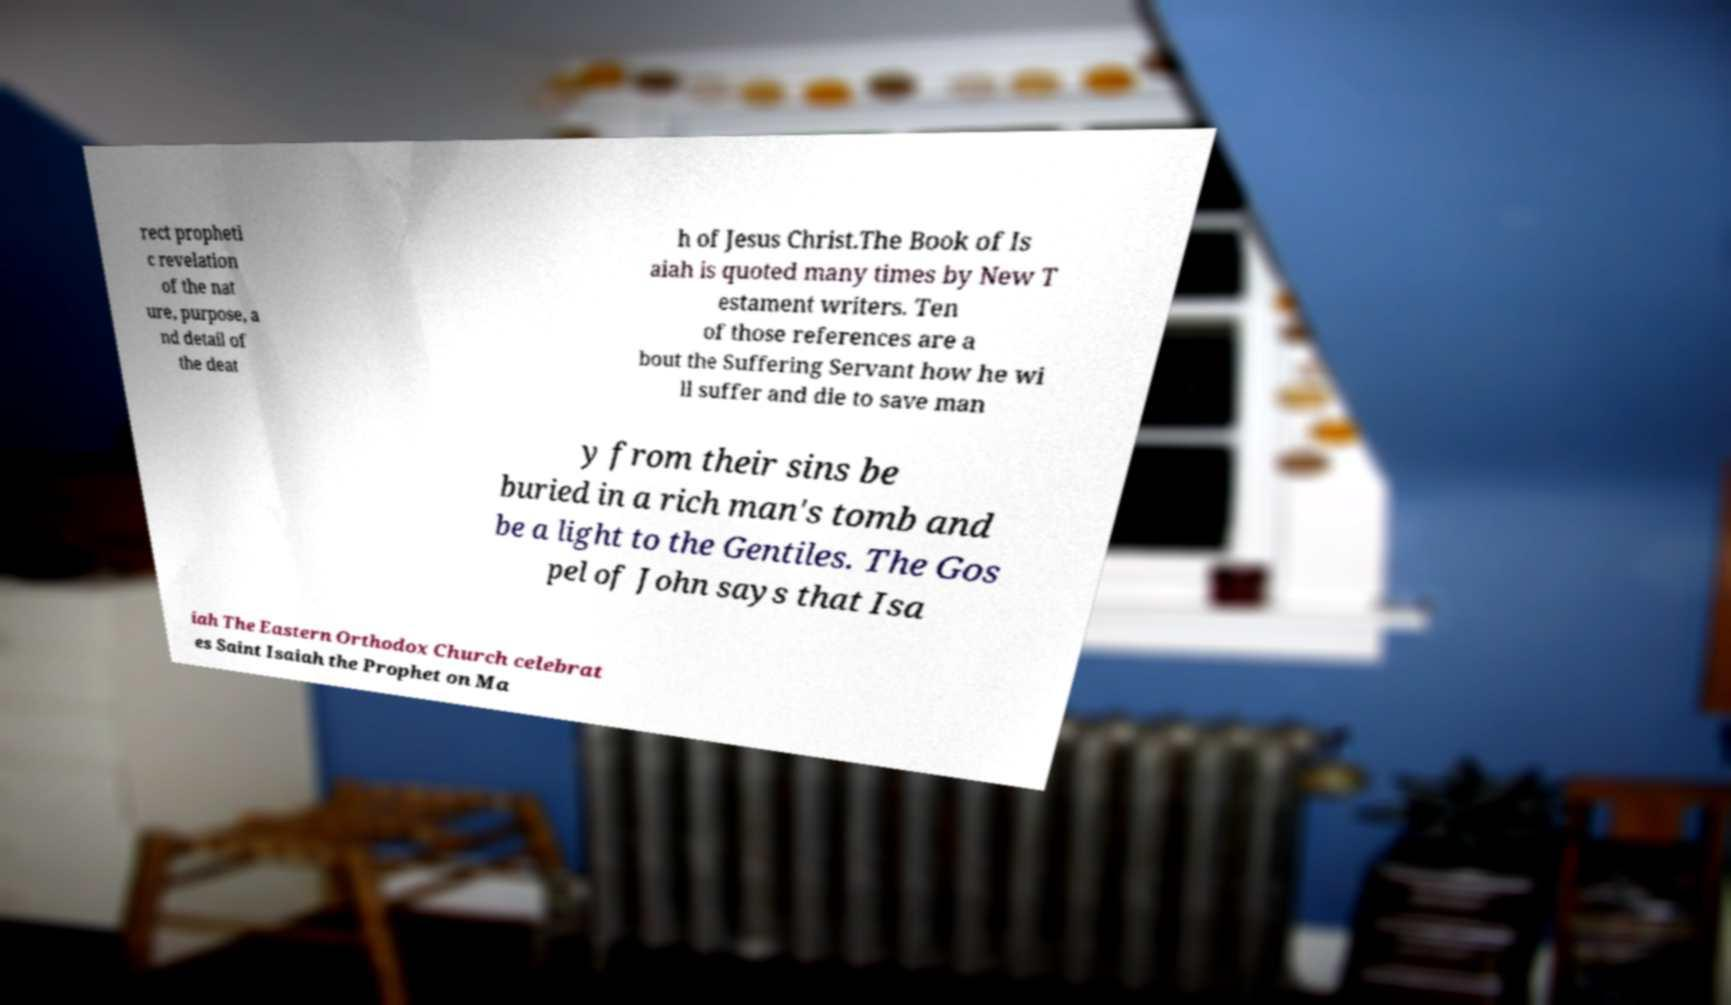There's text embedded in this image that I need extracted. Can you transcribe it verbatim? rect propheti c revelation of the nat ure, purpose, a nd detail of the deat h of Jesus Christ.The Book of Is aiah is quoted many times by New T estament writers. Ten of those references are a bout the Suffering Servant how he wi ll suffer and die to save man y from their sins be buried in a rich man's tomb and be a light to the Gentiles. The Gos pel of John says that Isa iah The Eastern Orthodox Church celebrat es Saint Isaiah the Prophet on Ma 